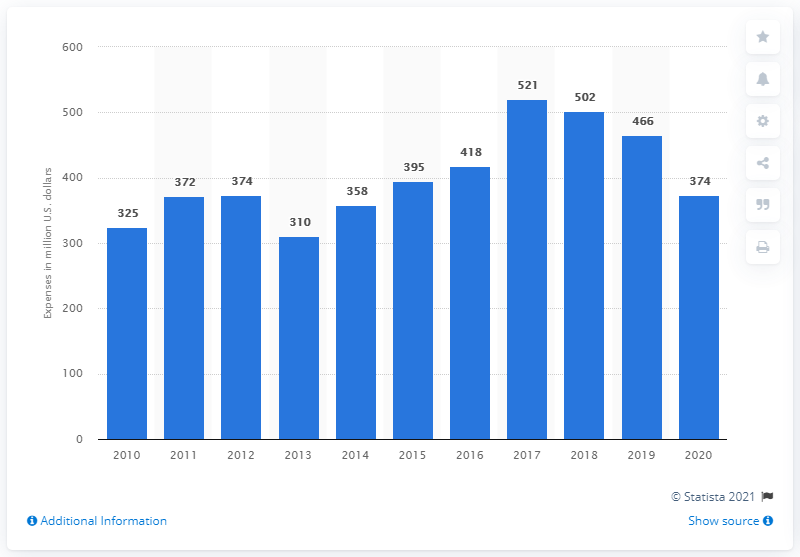Can you observe a general trend in R&D spending over the years? The trend in R&D spending by General Dynamics Corporation appears to be generally increasing over the years, with some fluctuations. There is a notable growth from 2015 onwards, peaking in 2019 before a downturn in 2020. 